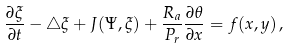Convert formula to latex. <formula><loc_0><loc_0><loc_500><loc_500>\frac { \partial \xi } { \partial t } - \triangle \xi + J ( \Psi , \xi ) + \frac { R _ { a } } { P _ { r } } \frac { \partial \theta } { \partial x } = f ( x , y ) \, ,</formula> 